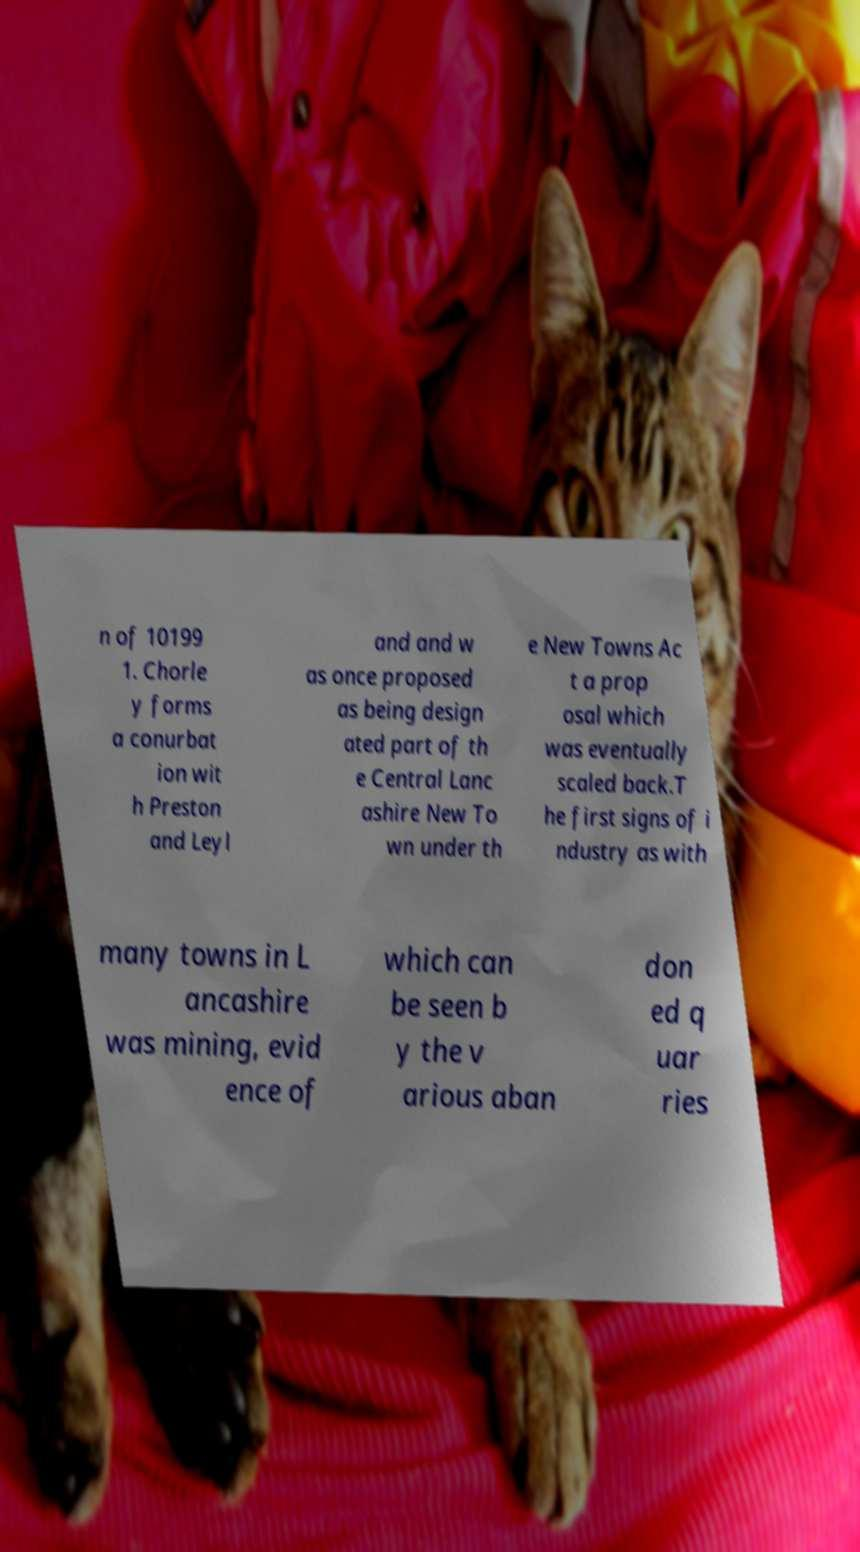For documentation purposes, I need the text within this image transcribed. Could you provide that? n of 10199 1. Chorle y forms a conurbat ion wit h Preston and Leyl and and w as once proposed as being design ated part of th e Central Lanc ashire New To wn under th e New Towns Ac t a prop osal which was eventually scaled back.T he first signs of i ndustry as with many towns in L ancashire was mining, evid ence of which can be seen b y the v arious aban don ed q uar ries 